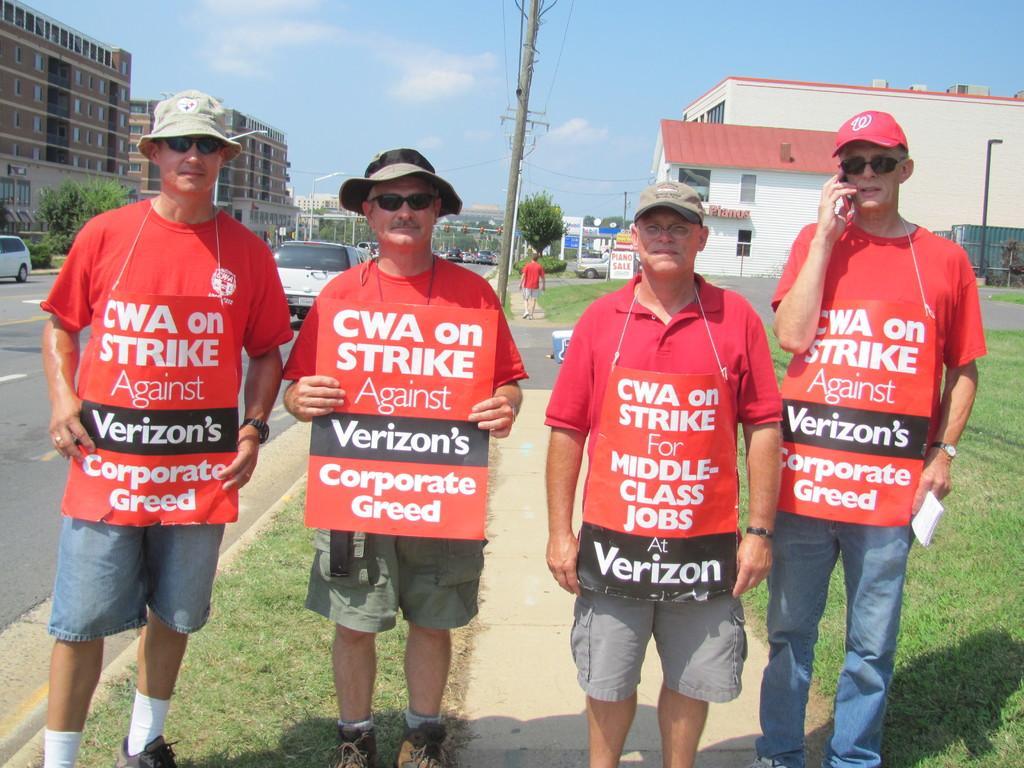How would you summarize this image in a sentence or two? In the center of the image we can see four people standing. They are wearing boards. At the bottom there is grass. On the left there is a road and we can see vehicles on the road. In the background there are buildings, trees, poles and sky. We can see a man walking. 